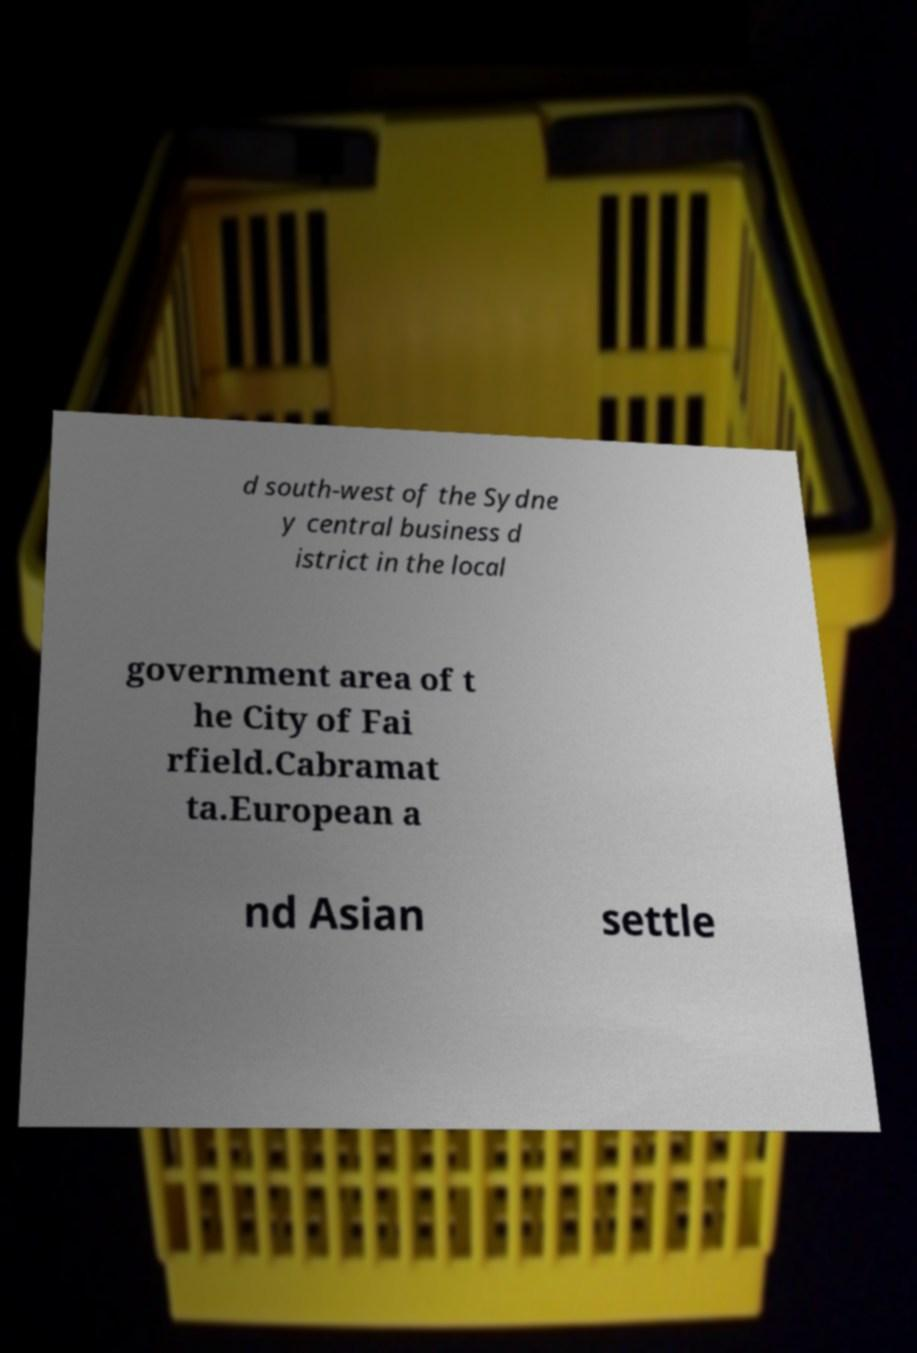Can you read and provide the text displayed in the image?This photo seems to have some interesting text. Can you extract and type it out for me? d south-west of the Sydne y central business d istrict in the local government area of t he City of Fai rfield.Cabramat ta.European a nd Asian settle 